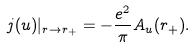Convert formula to latex. <formula><loc_0><loc_0><loc_500><loc_500>j ( u ) | _ { r \rightarrow r _ { + } } = - \frac { e ^ { 2 } } { \pi } A _ { u } ( r _ { + } ) . \label a { j u h o r i z o n }</formula> 